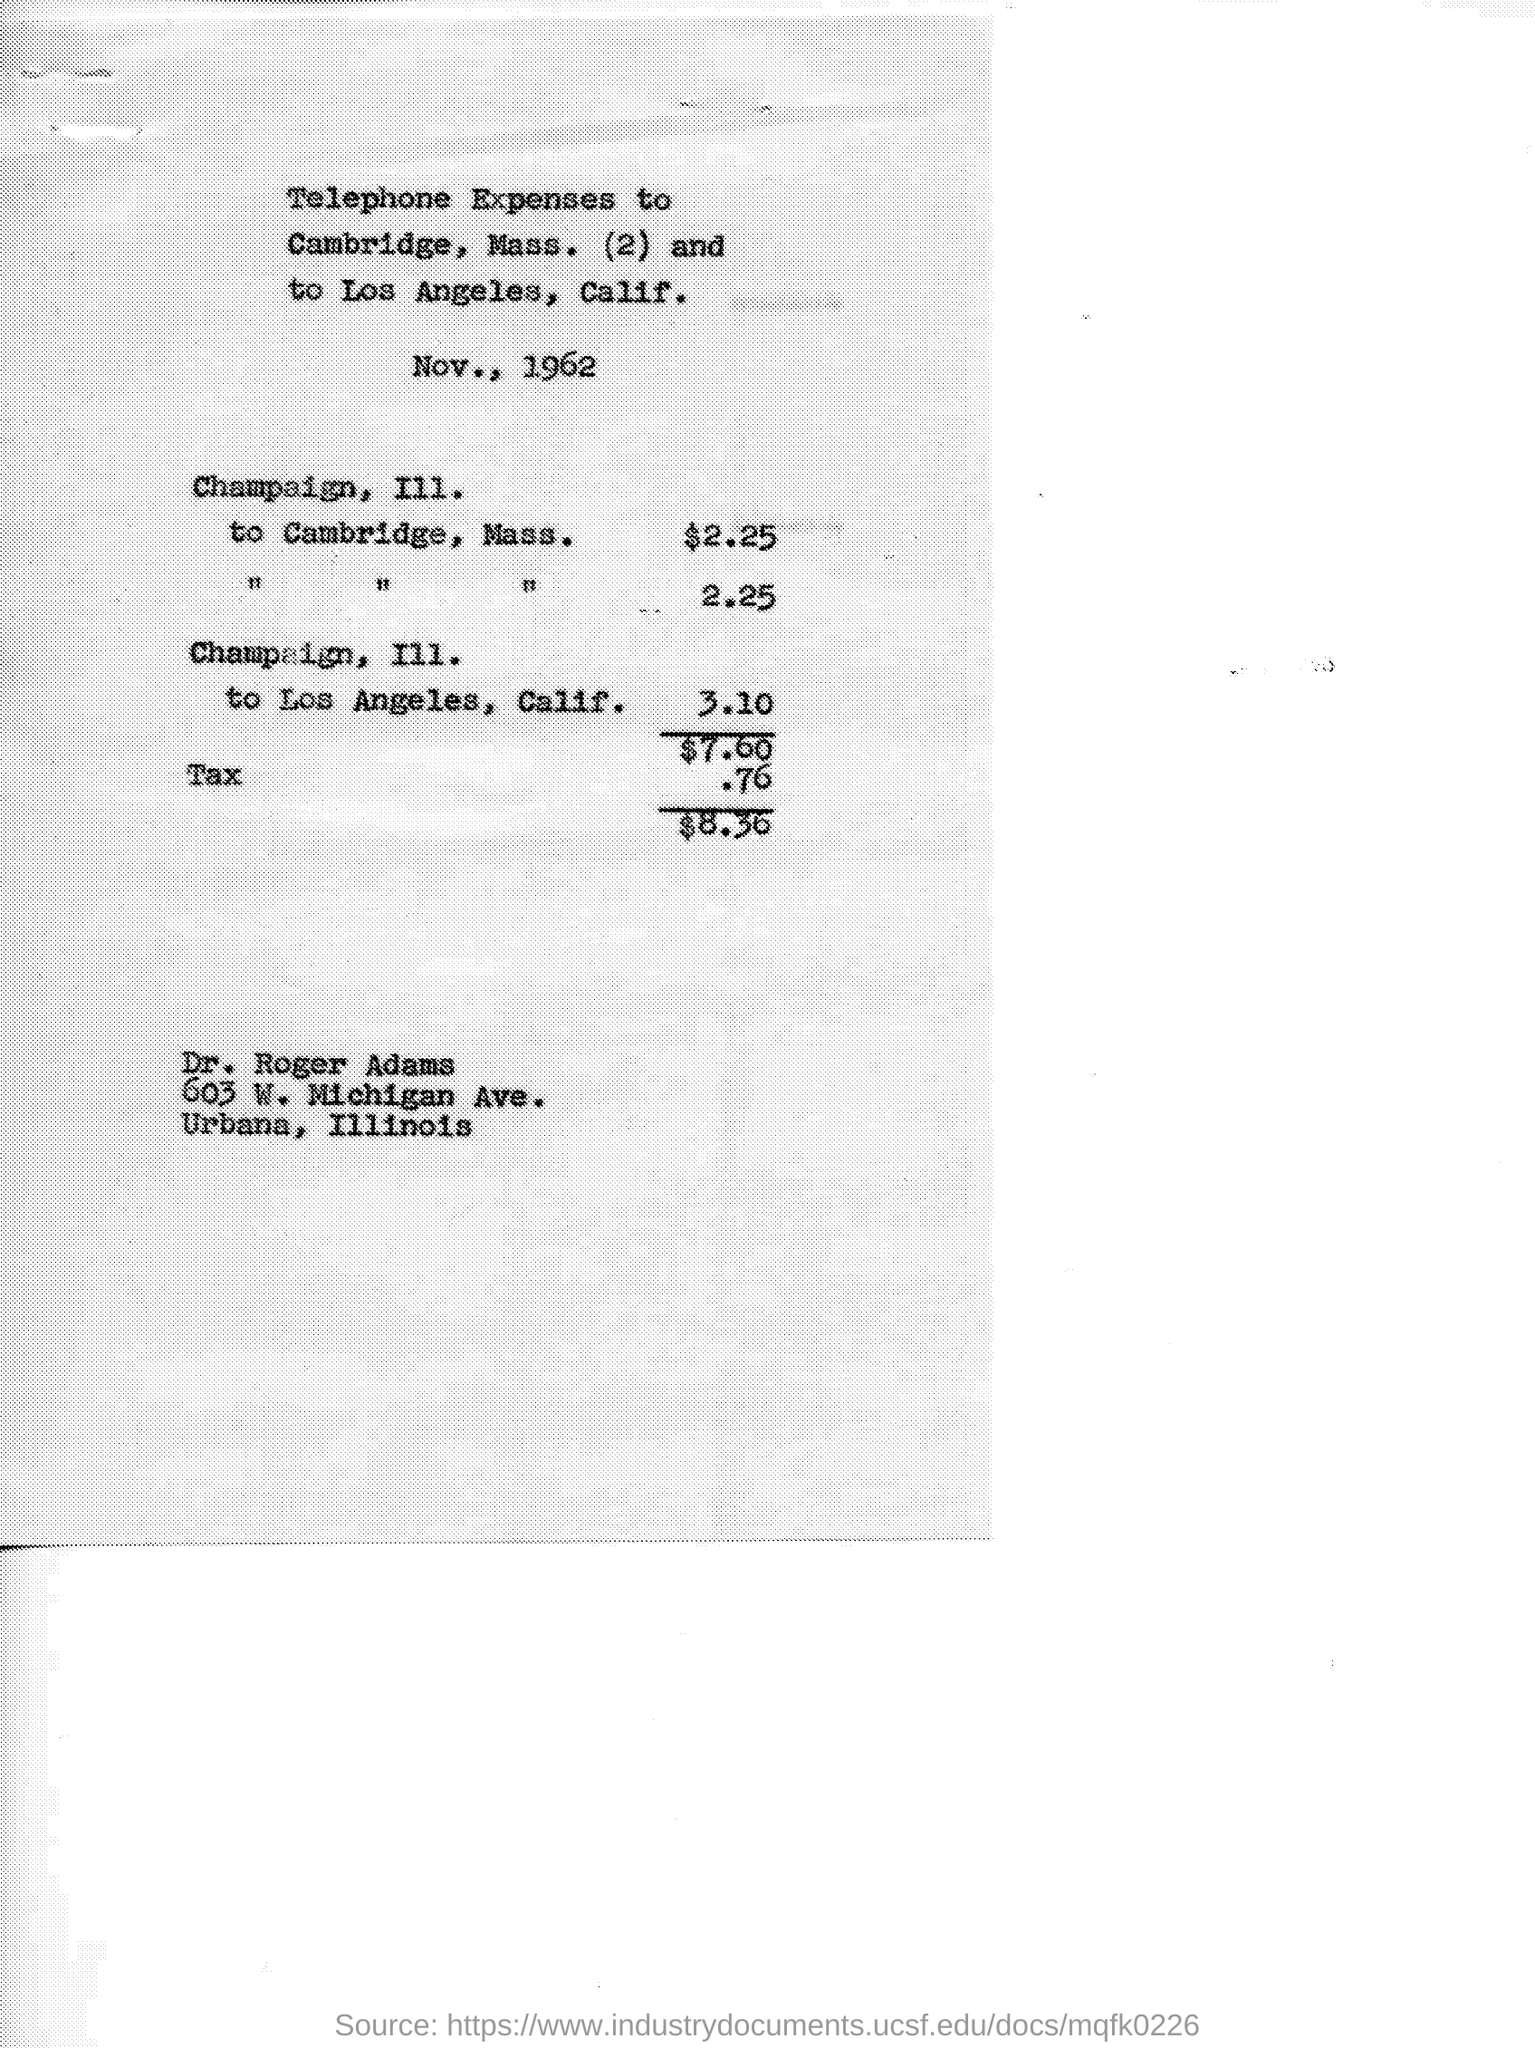Draw attention to some important aspects in this diagram. This text is about telephone expenses. The amount of money used for the trip from Champaign III. to Cambridge, Mass. was $2.25. The amount added as tax is 0.76. 